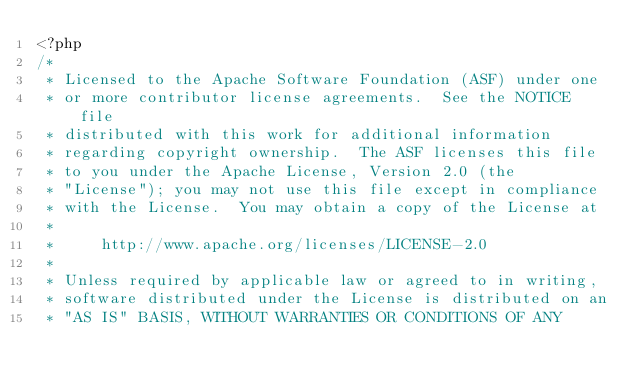Convert code to text. <code><loc_0><loc_0><loc_500><loc_500><_PHP_><?php
/*
 * Licensed to the Apache Software Foundation (ASF) under one
 * or more contributor license agreements.  See the NOTICE file
 * distributed with this work for additional information
 * regarding copyright ownership.  The ASF licenses this file
 * to you under the Apache License, Version 2.0 (the
 * "License"); you may not use this file except in compliance
 * with the License.  You may obtain a copy of the License at
 *
 *     http://www.apache.org/licenses/LICENSE-2.0
 *
 * Unless required by applicable law or agreed to in writing,
 * software distributed under the License is distributed on an
 * "AS IS" BASIS, WITHOUT WARRANTIES OR CONDITIONS OF ANY</code> 